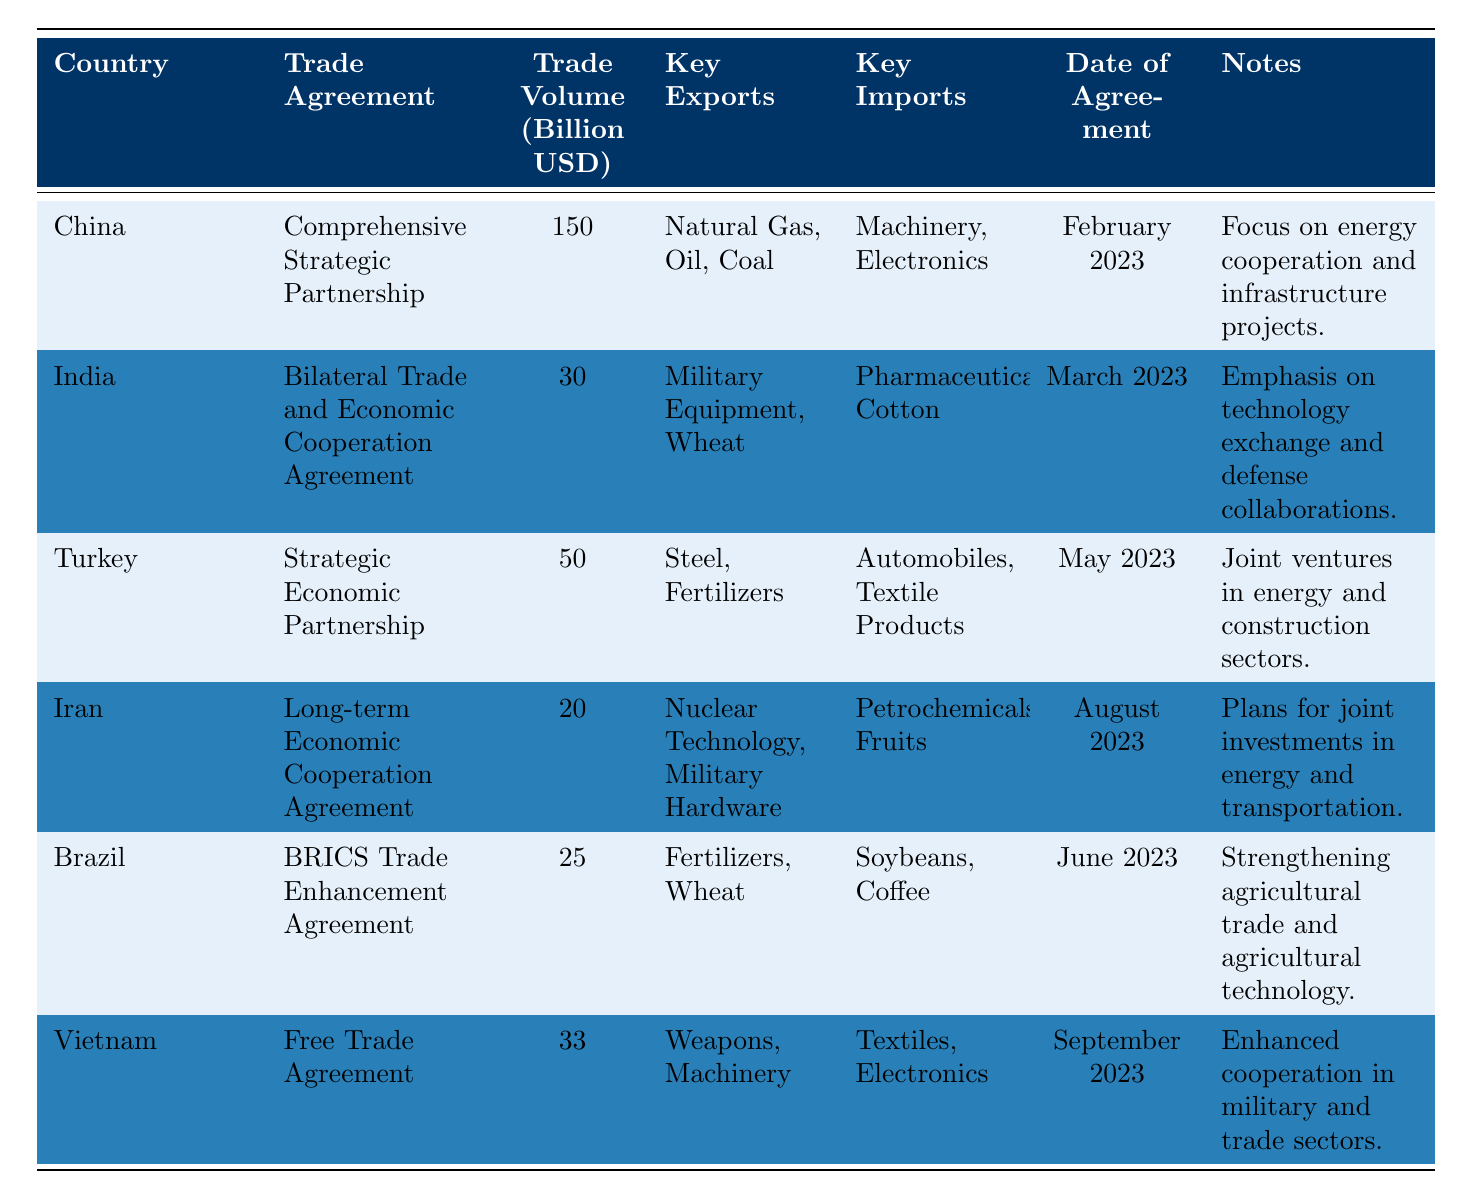What is the trade volume of the agreement with China? The table lists the trade volume for China under the "Trade Volume" column, which shows 150 billion USD.
Answer: 150 billion USD Which country has the lowest trade volume agreement? By comparing the "Trade Volume" values in the table, Iran has the lowest trade volume at 20 billion USD.
Answer: Iran What are the key exports from Brazil? The table specifies that Brazil's key exports are Fertilizers and Wheat as listed under the "Key Exports" column.
Answer: Fertilizers, Wheat How many trade agreements listed have a volume greater than 30 billion USD? The table shows China (150), Turkey (50), and Vietnam (33), which totals three agreements with volumes over 30 billion USD.
Answer: 3 Which country's trade agreement emphasizes technology exchange? According to the table, the agreement with India emphasizes technology exchange and defense collaborations as noted in the "Notes" section.
Answer: India What is the average trade volume of the agreements listed in the table? The total trade volume is (150 + 30 + 50 + 20 + 25 + 33) = 308 billion USD. There are 6 agreements, so the average is 308/6 = 51.33 billion USD.
Answer: 51.33 billion USD Does Turkey import automobiles according to the table? The table indicates that Turkey's key imports include Automobiles, making this statement true.
Answer: Yes What is the date of the trade agreement with Vietnam? The table indicates that the Vietnam trade agreement date is September 2023 under the "Date of Agreement" column.
Answer: September 2023 If we sum up the trade volumes of the agreements with Canada and Brazil, what is the result? Canada is not listed in the table, so we only consider Brazil, which has 25 billion USD; thus, the sum is 25 billion USD when considering Canada as 0.
Answer: 25 billion USD Which agreement has a focus on military and trade sectors? The table states that the agreement with Vietnam focuses on enhanced cooperation in military and trade sectors, which is noted in the "Notes" column.
Answer: Vietnam 